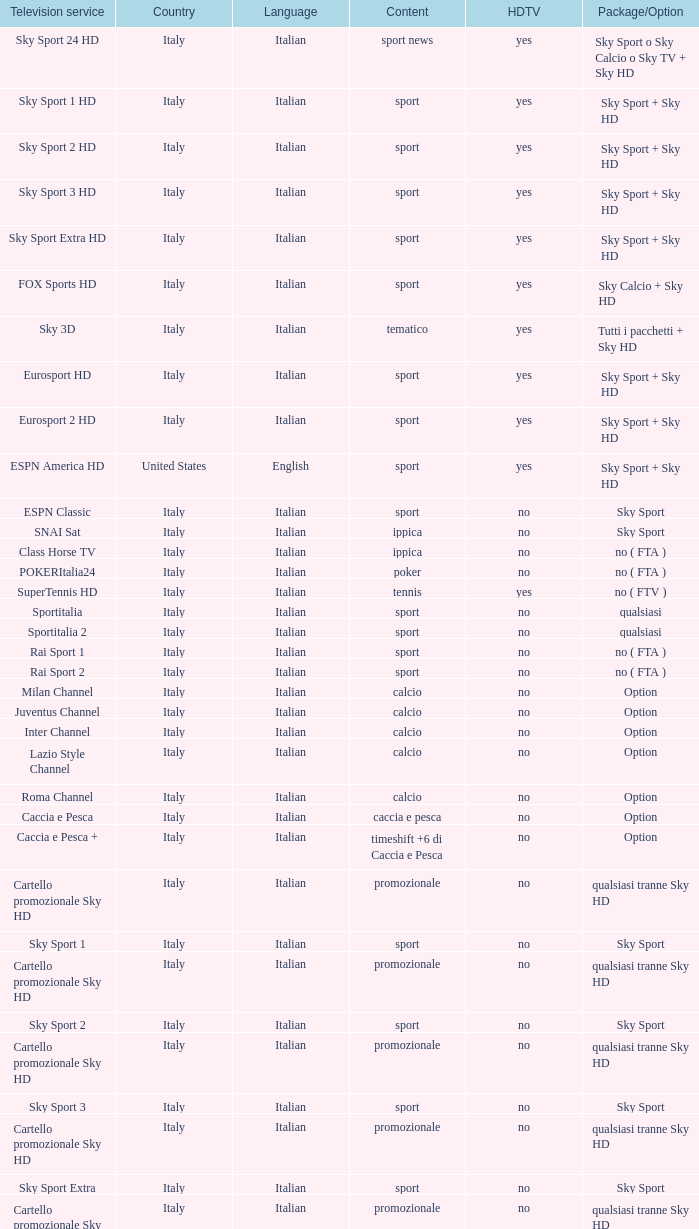What is the bundle/choice, when subject is tennis? No ( ftv ). 